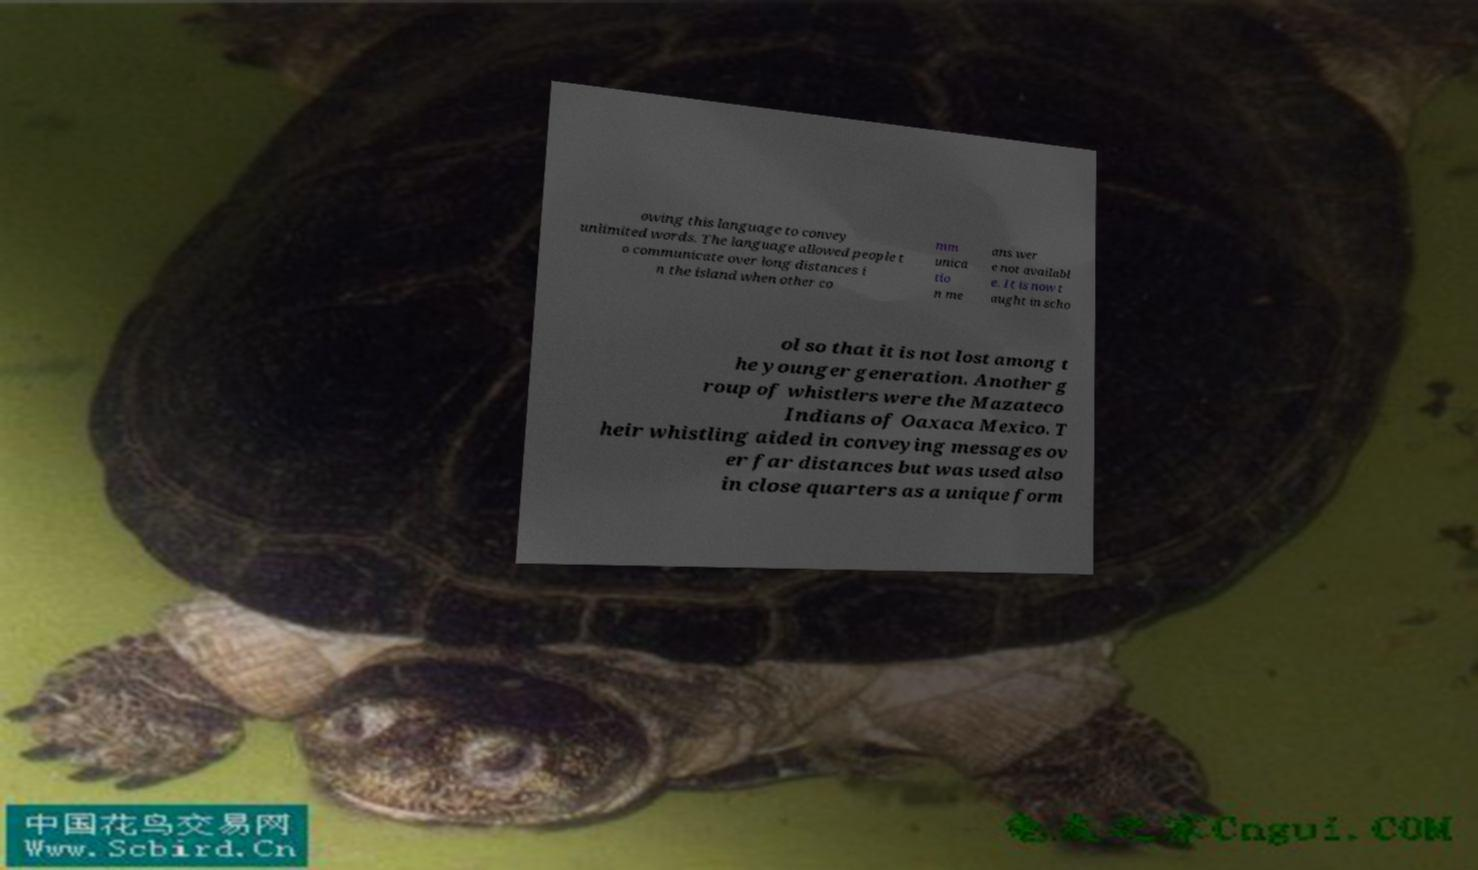Can you accurately transcribe the text from the provided image for me? owing this language to convey unlimited words. The language allowed people t o communicate over long distances i n the island when other co mm unica tio n me ans wer e not availabl e. It is now t aught in scho ol so that it is not lost among t he younger generation. Another g roup of whistlers were the Mazateco Indians of Oaxaca Mexico. T heir whistling aided in conveying messages ov er far distances but was used also in close quarters as a unique form 